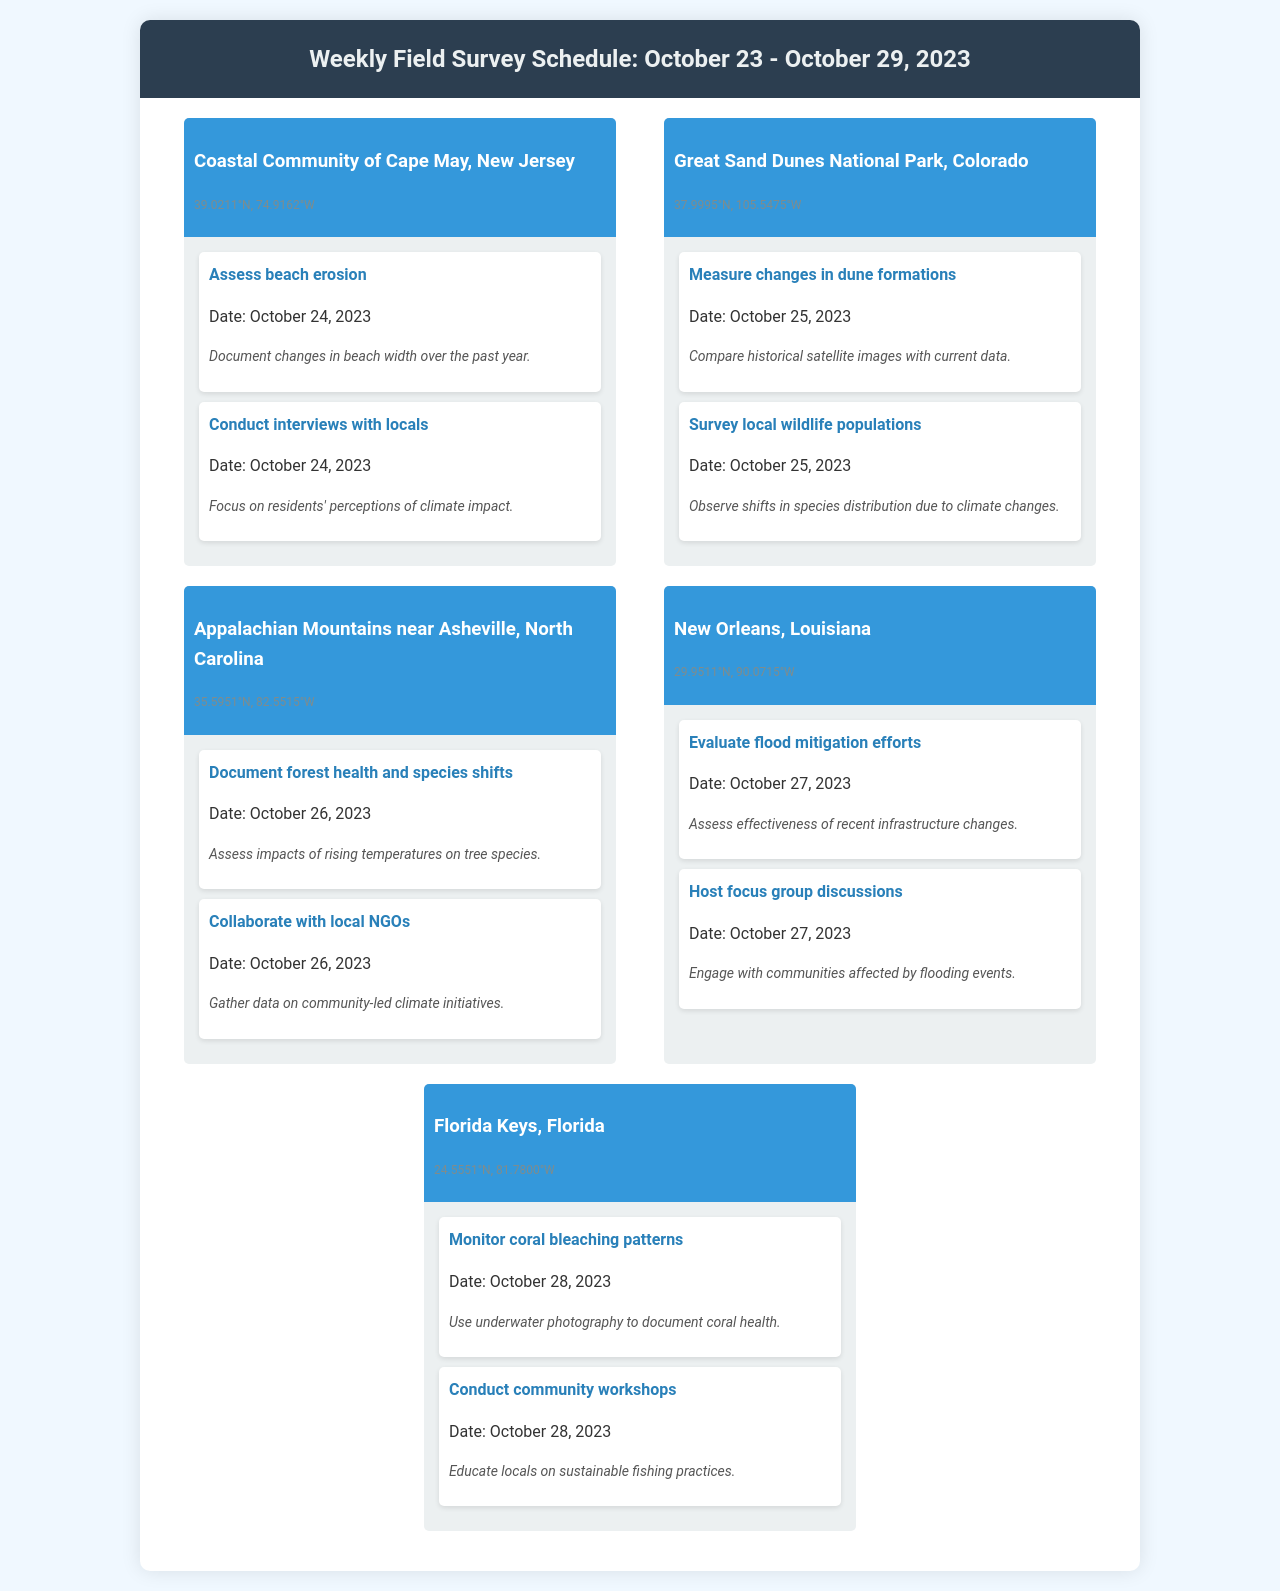What is the location of the first site visit? The first site visit is located in the Coastal Community of Cape May, New Jersey.
Answer: Coastal Community of Cape May, New Jersey What activity is scheduled for October 25, 2023, at Great Sand Dunes National Park? On October 25, 2023, the activity is to measure changes in dune formations.
Answer: Measure changes in dune formations How many activities are documented for the location of New Orleans, Louisiana? There are two activities documented for New Orleans, Louisiana, evaluating flood mitigation efforts and hosting focus groups.
Answer: Two Which community initiative will be researched in the Appalachian Mountains? The research will focus on community-led climate initiatives.
Answer: Community-led climate initiatives What is the date for monitoring coral bleaching patterns in the Florida Keys? The date for monitoring coral bleaching patterns is October 28, 2023.
Answer: October 28, 2023 What type of data will be gathered in Cape May? There will be data on beach erosion and residents' perceptions of climate impact.
Answer: Beach erosion and residents' perceptions of climate impact Which region is associated with the coordinates 29.9511°N, 90.0715°W? Those coordinates correspond to New Orleans, Louisiana.
Answer: New Orleans, Louisiana What specific aspect of the local wildlife will be surveyed in Colorado? The survey will observe shifts in species distribution due to climate changes.
Answer: Shifts in species distribution due to climate changes 